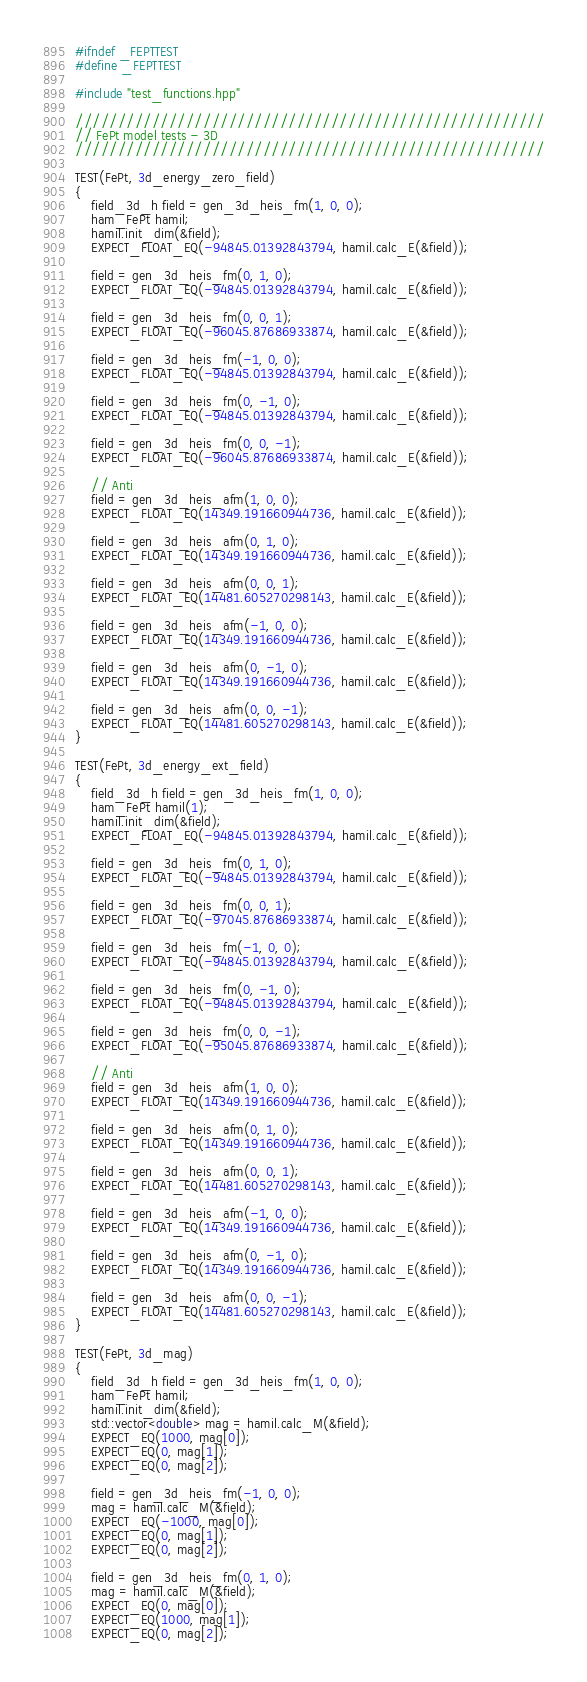Convert code to text. <code><loc_0><loc_0><loc_500><loc_500><_C++_>#ifndef _FEPTTEST
#define _FEPTTEST

#include "test_functions.hpp"

///////////////////////////////////////////////////////
// FePt model tests - 3D
///////////////////////////////////////////////////////

TEST(FePt, 3d_energy_zero_field)
{
    field_3d_h field = gen_3d_heis_fm(1, 0, 0);
    ham_FePt hamil;
    hamil.init_dim(&field);
    EXPECT_FLOAT_EQ(-94845.01392843794, hamil.calc_E(&field));

    field = gen_3d_heis_fm(0, 1, 0);
    EXPECT_FLOAT_EQ(-94845.01392843794, hamil.calc_E(&field));

    field = gen_3d_heis_fm(0, 0, 1);
    EXPECT_FLOAT_EQ(-96045.87686933874, hamil.calc_E(&field));

    field = gen_3d_heis_fm(-1, 0, 0);
    EXPECT_FLOAT_EQ(-94845.01392843794, hamil.calc_E(&field));

    field = gen_3d_heis_fm(0, -1, 0);
    EXPECT_FLOAT_EQ(-94845.01392843794, hamil.calc_E(&field));

    field = gen_3d_heis_fm(0, 0, -1);
    EXPECT_FLOAT_EQ(-96045.87686933874, hamil.calc_E(&field));

    // Anti
    field = gen_3d_heis_afm(1, 0, 0);
    EXPECT_FLOAT_EQ(14349.191660944736, hamil.calc_E(&field));

    field = gen_3d_heis_afm(0, 1, 0);
    EXPECT_FLOAT_EQ(14349.191660944736, hamil.calc_E(&field));

    field = gen_3d_heis_afm(0, 0, 1);
    EXPECT_FLOAT_EQ(14481.605270298143, hamil.calc_E(&field));

    field = gen_3d_heis_afm(-1, 0, 0);
    EXPECT_FLOAT_EQ(14349.191660944736, hamil.calc_E(&field));

    field = gen_3d_heis_afm(0, -1, 0);
    EXPECT_FLOAT_EQ(14349.191660944736, hamil.calc_E(&field));

    field = gen_3d_heis_afm(0, 0, -1);
    EXPECT_FLOAT_EQ(14481.605270298143, hamil.calc_E(&field));
}

TEST(FePt, 3d_energy_ext_field)
{
    field_3d_h field = gen_3d_heis_fm(1, 0, 0);
    ham_FePt hamil(1);
    hamil.init_dim(&field);
    EXPECT_FLOAT_EQ(-94845.01392843794, hamil.calc_E(&field));

    field = gen_3d_heis_fm(0, 1, 0);
    EXPECT_FLOAT_EQ(-94845.01392843794, hamil.calc_E(&field));

    field = gen_3d_heis_fm(0, 0, 1);
    EXPECT_FLOAT_EQ(-97045.87686933874, hamil.calc_E(&field));

    field = gen_3d_heis_fm(-1, 0, 0);
    EXPECT_FLOAT_EQ(-94845.01392843794, hamil.calc_E(&field));

    field = gen_3d_heis_fm(0, -1, 0);
    EXPECT_FLOAT_EQ(-94845.01392843794, hamil.calc_E(&field));

    field = gen_3d_heis_fm(0, 0, -1);
    EXPECT_FLOAT_EQ(-95045.87686933874, hamil.calc_E(&field));

    // Anti
    field = gen_3d_heis_afm(1, 0, 0);
    EXPECT_FLOAT_EQ(14349.191660944736, hamil.calc_E(&field));

    field = gen_3d_heis_afm(0, 1, 0);
    EXPECT_FLOAT_EQ(14349.191660944736, hamil.calc_E(&field));

    field = gen_3d_heis_afm(0, 0, 1);
    EXPECT_FLOAT_EQ(14481.605270298143, hamil.calc_E(&field));

    field = gen_3d_heis_afm(-1, 0, 0);
    EXPECT_FLOAT_EQ(14349.191660944736, hamil.calc_E(&field));

    field = gen_3d_heis_afm(0, -1, 0);
    EXPECT_FLOAT_EQ(14349.191660944736, hamil.calc_E(&field));

    field = gen_3d_heis_afm(0, 0, -1);
    EXPECT_FLOAT_EQ(14481.605270298143, hamil.calc_E(&field));
}

TEST(FePt, 3d_mag)
{
    field_3d_h field = gen_3d_heis_fm(1, 0, 0);
    ham_FePt hamil;
    hamil.init_dim(&field);
    std::vector<double> mag = hamil.calc_M(&field);
    EXPECT_EQ(1000, mag[0]);
    EXPECT_EQ(0, mag[1]);
    EXPECT_EQ(0, mag[2]);

    field = gen_3d_heis_fm(-1, 0, 0);
    mag = hamil.calc_M(&field);
    EXPECT_EQ(-1000, mag[0]);
    EXPECT_EQ(0, mag[1]);
    EXPECT_EQ(0, mag[2]);

    field = gen_3d_heis_fm(0, 1, 0);
    mag = hamil.calc_M(&field);
    EXPECT_EQ(0, mag[0]);
    EXPECT_EQ(1000, mag[1]);
    EXPECT_EQ(0, mag[2]);
</code> 